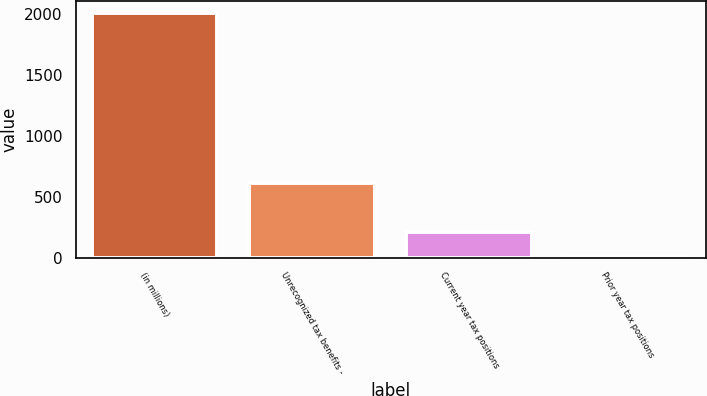Convert chart to OTSL. <chart><loc_0><loc_0><loc_500><loc_500><bar_chart><fcel>(in millions)<fcel>Unrecognized tax benefits -<fcel>Current year tax positions<fcel>Prior year tax positions<nl><fcel>2014<fcel>609.1<fcel>207.7<fcel>7<nl></chart> 